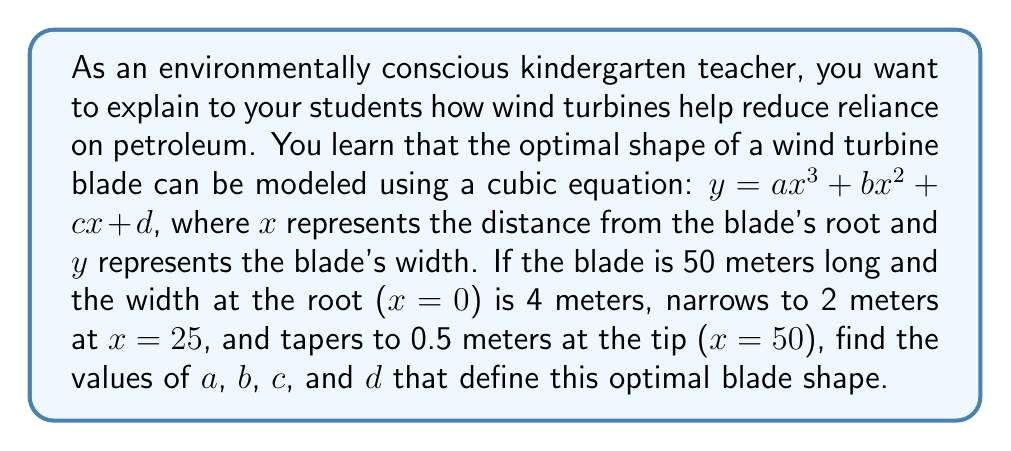Solve this math problem. Let's approach this step-by-step:

1) We have three points on the curve:
   $(0, 4)$, $(25, 2)$, and $(50, 0.5)$

2) We can set up three equations using these points:
   $4 = a(0)^3 + b(0)^2 + c(0) + d$
   $2 = a(25)^3 + b(25)^2 + c(25) + d$
   $0.5 = a(50)^3 + b(50)^2 + c(50) + d$

3) Simplify the first equation:
   $4 = d$

4) Substitute this into the other two equations:
   $2 = 15625a + 625b + 25c + 4$
   $0.5 = 125000a + 2500b + 50c + 4$

5) Subtract the first equation from the second:
   $-1.5 = 109375a + 1875b + 25c$

6) We need one more equation. We can use the fact that the derivative of the function at $x=50$ should be close to zero for a smooth taper. The derivative is:
   $y' = 3ax^2 + 2bx + c$
   At $x=50$: $0 ≈ 7500a + 100b + c$

7) Now we have a system of four equations:
   $d = 4$
   $-2 = 15625a + 625b + 25c$
   $-3.5 = 125000a + 2500b + 50c$
   $0 ≈ 7500a + 100b + c$

8) Solving this system (using a computer algebra system for efficiency):
   $a ≈ -0.0000256$
   $b ≈ 0.00192$
   $c ≈ -0.0480$
   $d = 4$

9) Therefore, the cubic equation modeling the optimal blade shape is approximately:
   $y = -0.0000256x^3 + 0.00192x^2 - 0.0480x + 4$
Answer: $y = -0.0000256x^3 + 0.00192x^2 - 0.0480x + 4$ 